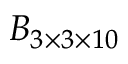<formula> <loc_0><loc_0><loc_500><loc_500>B _ { 3 \times 3 \times 1 0 }</formula> 